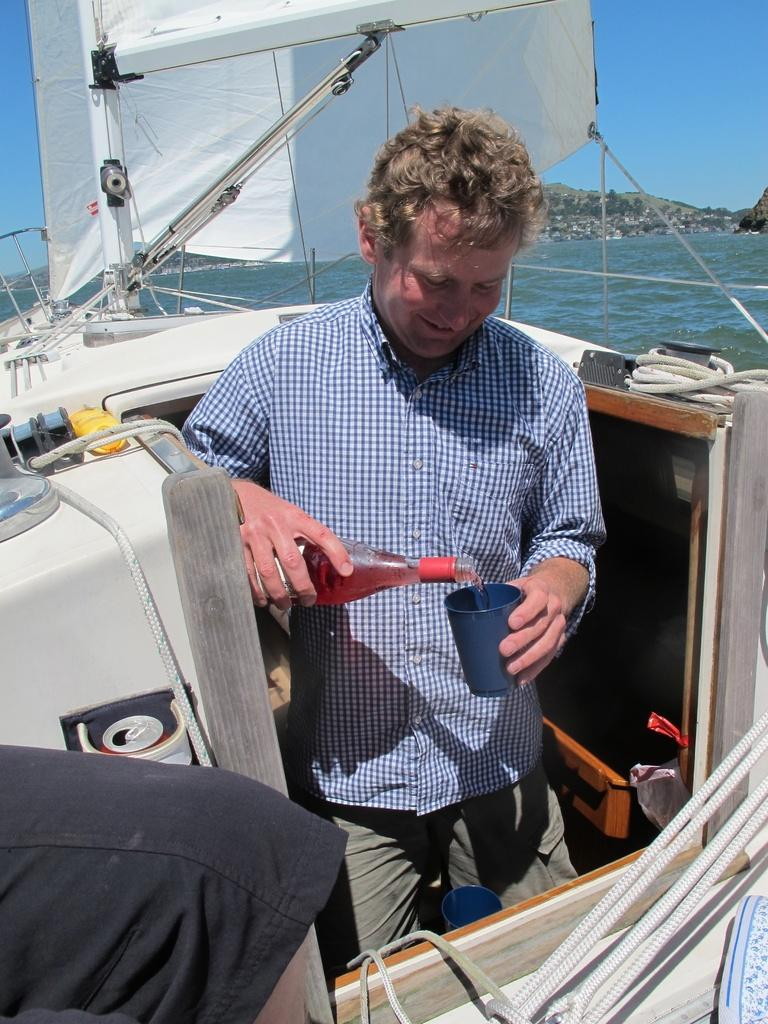What is the man in the image holding in his hands? The man is holding a bottle and a cup in his hands. What else can be seen in the image besides the man and his belongings? There are ropes, a cloth, and water visible in the background. What type of landscape is visible in the background? A hill and the sky are visible in the background. What is the primary mode of transportation in the image? It is a boat in the image. What type of crayon is the man using to draw on the boat? There is no crayon present in the image, and the man is not drawing on the boat. 